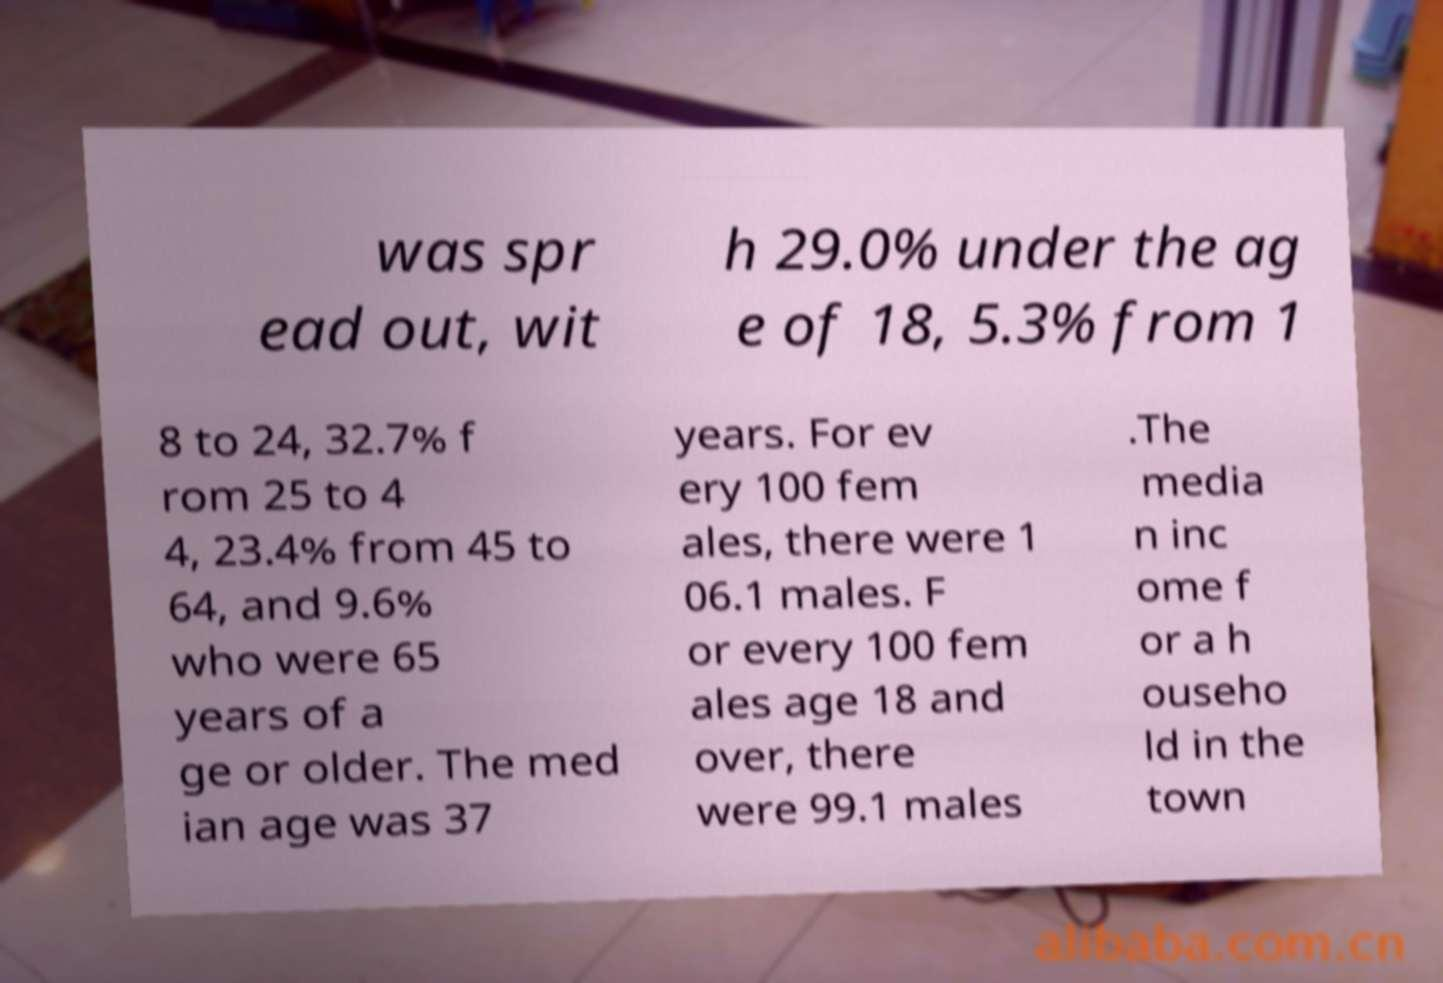For documentation purposes, I need the text within this image transcribed. Could you provide that? was spr ead out, wit h 29.0% under the ag e of 18, 5.3% from 1 8 to 24, 32.7% f rom 25 to 4 4, 23.4% from 45 to 64, and 9.6% who were 65 years of a ge or older. The med ian age was 37 years. For ev ery 100 fem ales, there were 1 06.1 males. F or every 100 fem ales age 18 and over, there were 99.1 males .The media n inc ome f or a h ouseho ld in the town 